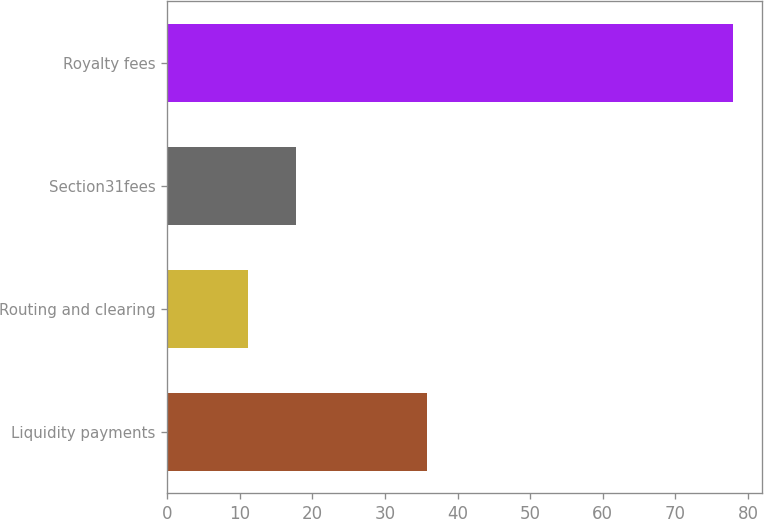Convert chart. <chart><loc_0><loc_0><loc_500><loc_500><bar_chart><fcel>Liquidity payments<fcel>Routing and clearing<fcel>Section31fees<fcel>Royalty fees<nl><fcel>35.8<fcel>11.1<fcel>17.79<fcel>78<nl></chart> 